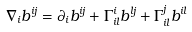Convert formula to latex. <formula><loc_0><loc_0><loc_500><loc_500>\nabla _ { i } b ^ { i j } = \partial _ { i } b ^ { i j } + \Gamma _ { i l } ^ { i } b ^ { l j } + \Gamma _ { i l } ^ { j } b ^ { i l }</formula> 